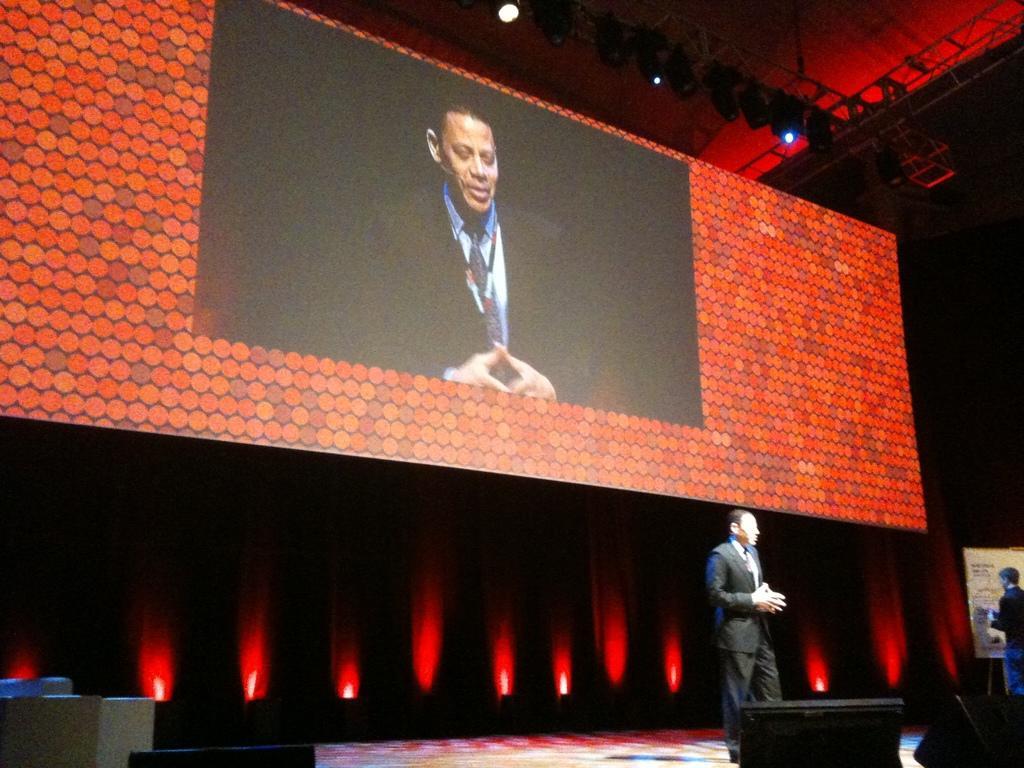How would you summarize this image in a sentence or two? In this picture we can see two persons are standing, on the right side there is a board, in the background we can see a screen, we can see a person on the screen, there are some lights at the top of the picture. 